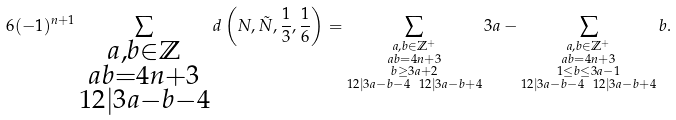<formula> <loc_0><loc_0><loc_500><loc_500>6 ( - 1 ) ^ { n + 1 } \sum _ { \substack { a , b \in \mathbb { Z } \\ a b = 4 n + 3 \\ 1 2 | 3 a - b - 4 } } d \left ( N , \tilde { N } , \frac { 1 } { 3 } , \frac { 1 } { 6 } \right ) & = \sum _ { \substack { a , b \in \mathbb { Z } ^ { + } \\ a b = 4 n + 3 \\ b \geq 3 a + 2 \\ 1 2 | 3 a - b - 4 \ \ 1 2 | 3 a - b + 4 } } 3 a - \sum _ { \substack { a , b \in \mathbb { Z } ^ { + } \\ a b = 4 n + 3 \\ 1 \leq b \leq 3 a - 1 \\ 1 2 | 3 a - b - 4 \ \ 1 2 | 3 a - b + 4 } } b .</formula> 